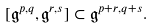Convert formula to latex. <formula><loc_0><loc_0><loc_500><loc_500>[ \mathfrak { g } ^ { p , q } , \mathfrak { g } ^ { r , s } ] \subset \mathfrak { g } ^ { p + r , q + s } .</formula> 